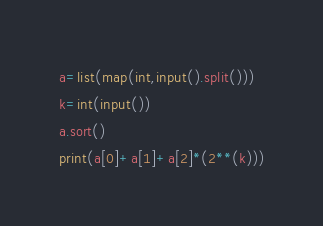<code> <loc_0><loc_0><loc_500><loc_500><_Python_>a=list(map(int,input().split()))
k=int(input())
a.sort()
print(a[0]+a[1]+a[2]*(2**(k)))</code> 